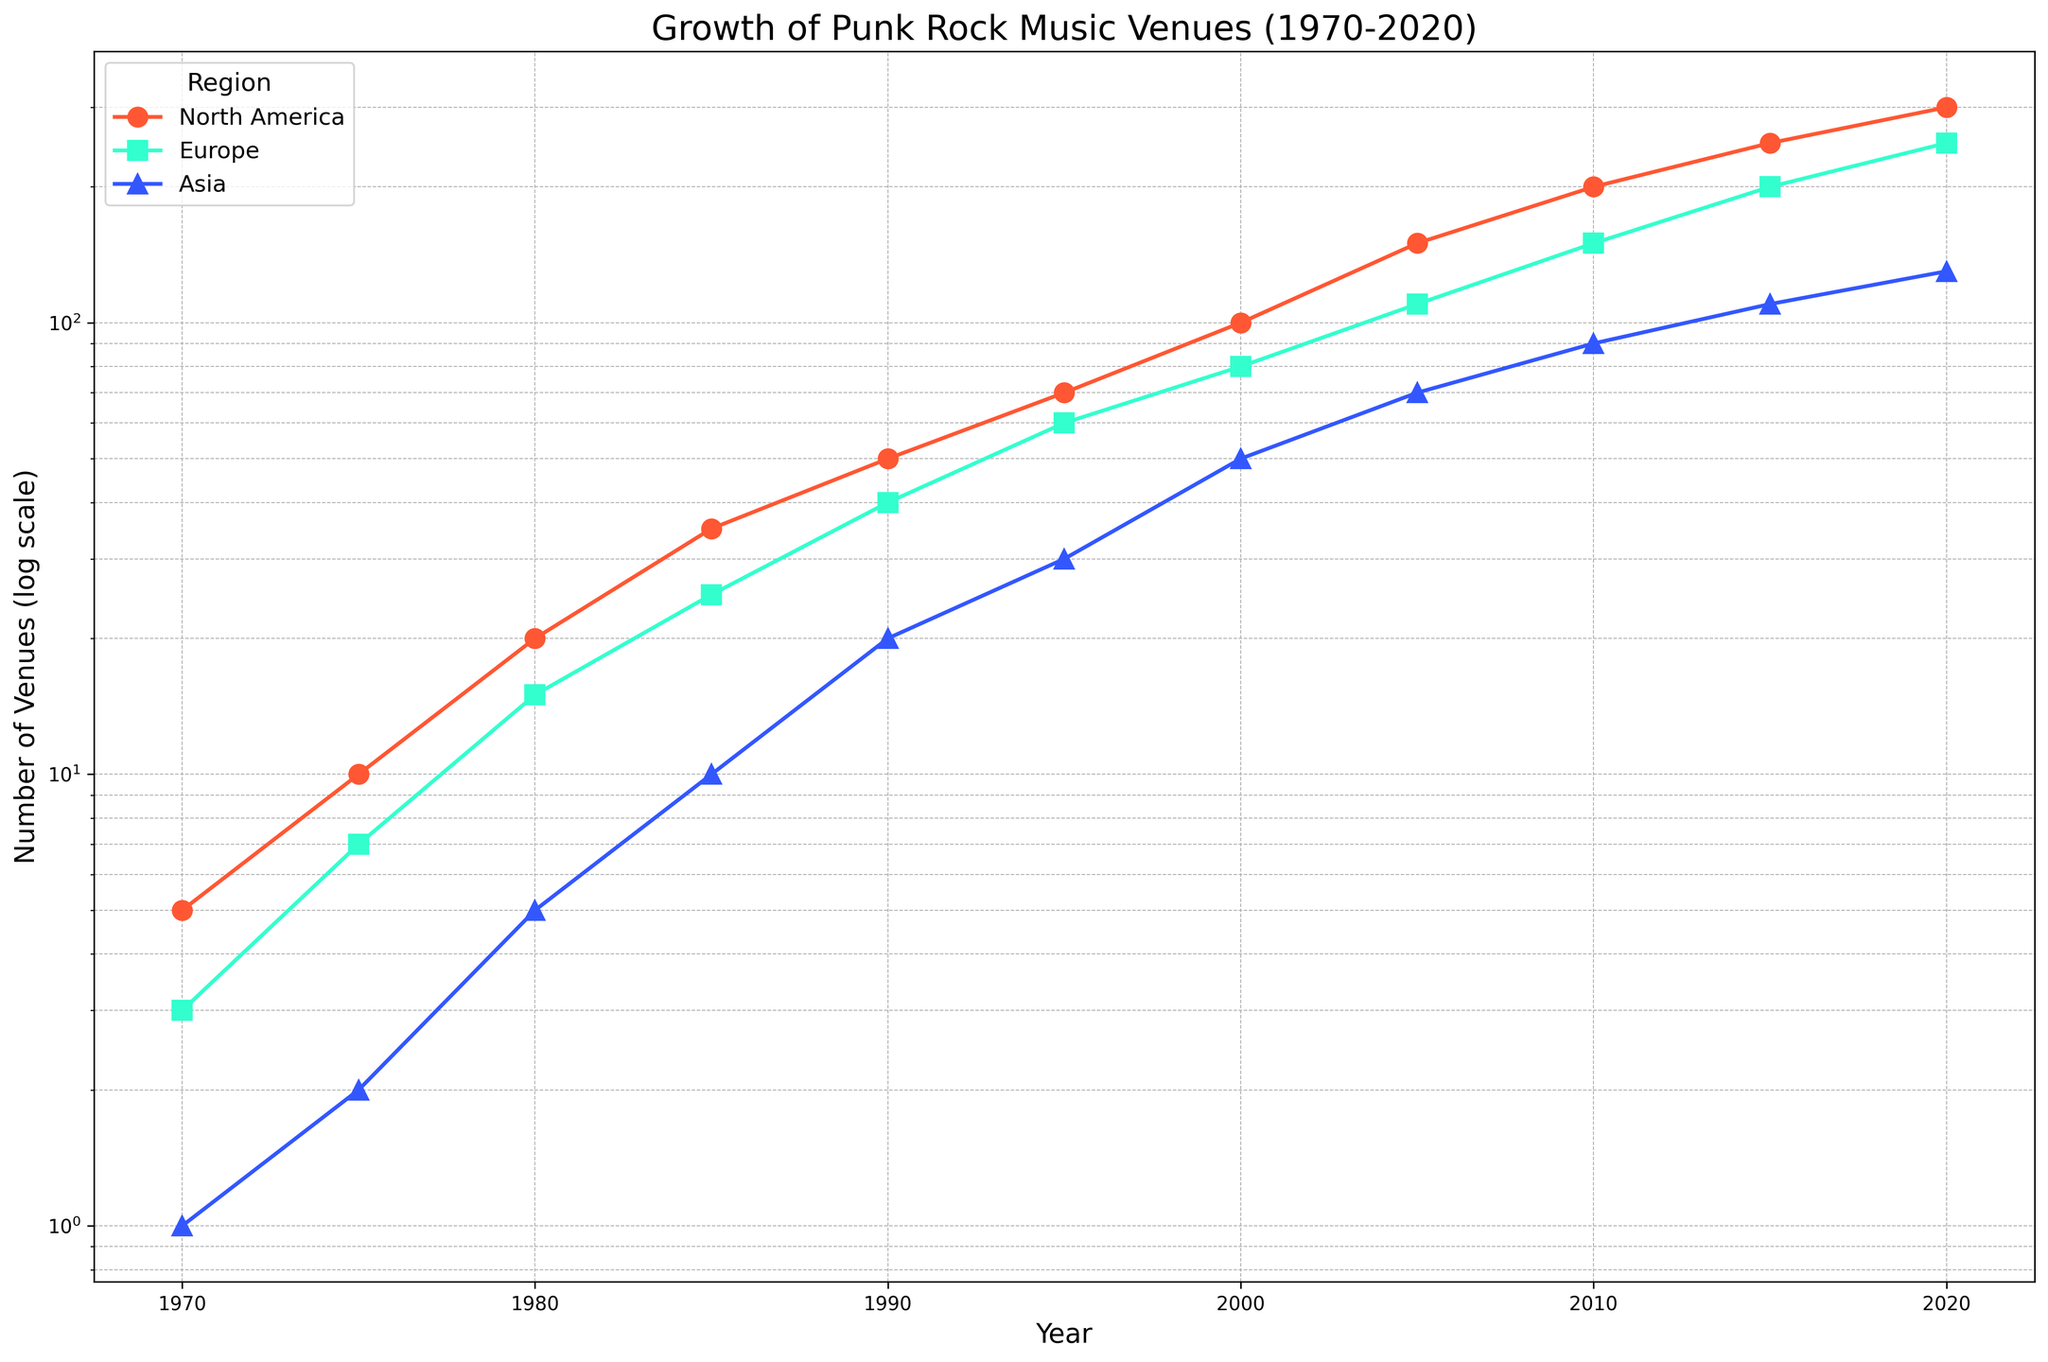What region shows the steepest growth in punk rock music venues from 1970 to 2020? First, identify the trends of all regions on the log scale. North America starts from 5 venues in 1970 and reaches 300 in 2020, showing the most significant increase relative to Europe and Asia. Hence, North America has the steepest growth.
Answer: North America In 1990, which region had the highest number of punk rock music venues? From the figure, in 1990, North America has 50 venues, Europe has 40 venues, and Asia has 20 venues. Comparing these values, North America has the highest number of venues.
Answer: North America How did the number of venues in Europe change from 1980 to 2000? Europe had 15 venues in 1980 and 80 venues in 2000. The difference is 80 - 15 = 65, meaning there was an increase of 65 venues.
Answer: Increased by 65 What is the total number of venues across all regions in 2010? According to the data, in 2010, North America had 200 venues, Europe had 150, and Asia had 90. Summing these, 200 + 150 + 90 = 440 venues in total.
Answer: 440 Compare the growth rate of punk rock venues in Asia from 1995 to 2005 with that from 2005 to 2015. Which period saw a higher growth rate? From 1995 to 2005, Asia increased from 30 to 70 venues, a growth rate of (70-30)/30 = 1.33 (or 133%). From 2005 to 2015, it increased from 70 to 110, a growth rate of (110-70)/70 = 0.57 (or 57%). The period from 1995 to 2005 had a higher growth rate.
Answer: 1995 to 2005 What's the average number of venues in North America in the years 1970, 1980, and 1990? In these years, North America had 5, 20, and 50 venues, respectively. The average is (5 + 20 + 50) / 3 = 25.
Answer: 25 Which region showed the smallest growth in the number of punk rock venues between 1970 and 2020? Asia starts with 1 venue in 1970 and reaches 130 in 2020. Both North America and Europe start with larger numbers and have more significant increases. Therefore, Asia has the smallest growth.
Answer: Asia How does the growth in Europe from 1970 to 2020 compare to that in North America over the same period in terms of the multiple increase? Europe increased from 3 to 250, which is 250/3 ≈ 83 times. North America increased from 5 to 300, which is 300/5 = 60 times. Europe’s increase is larger in terms of multiples.
Answer: Europe by multiples In which decade did North America see the largest numerical increase in punk rock venues? Inspect the plot for the largest upward shift in venues for North America between decades. The largest increase occurred between 2000 (100 venues) and 2010 (200 venues) with a numerical increase of 100 venues.
Answer: 2000-2010 What is the ratio of venues in North America to Europe in 2020? In 2020, North America has 300 venues, and Europe has 250 venues. The ratio is 300/250 = 1.2.
Answer: 1.2 